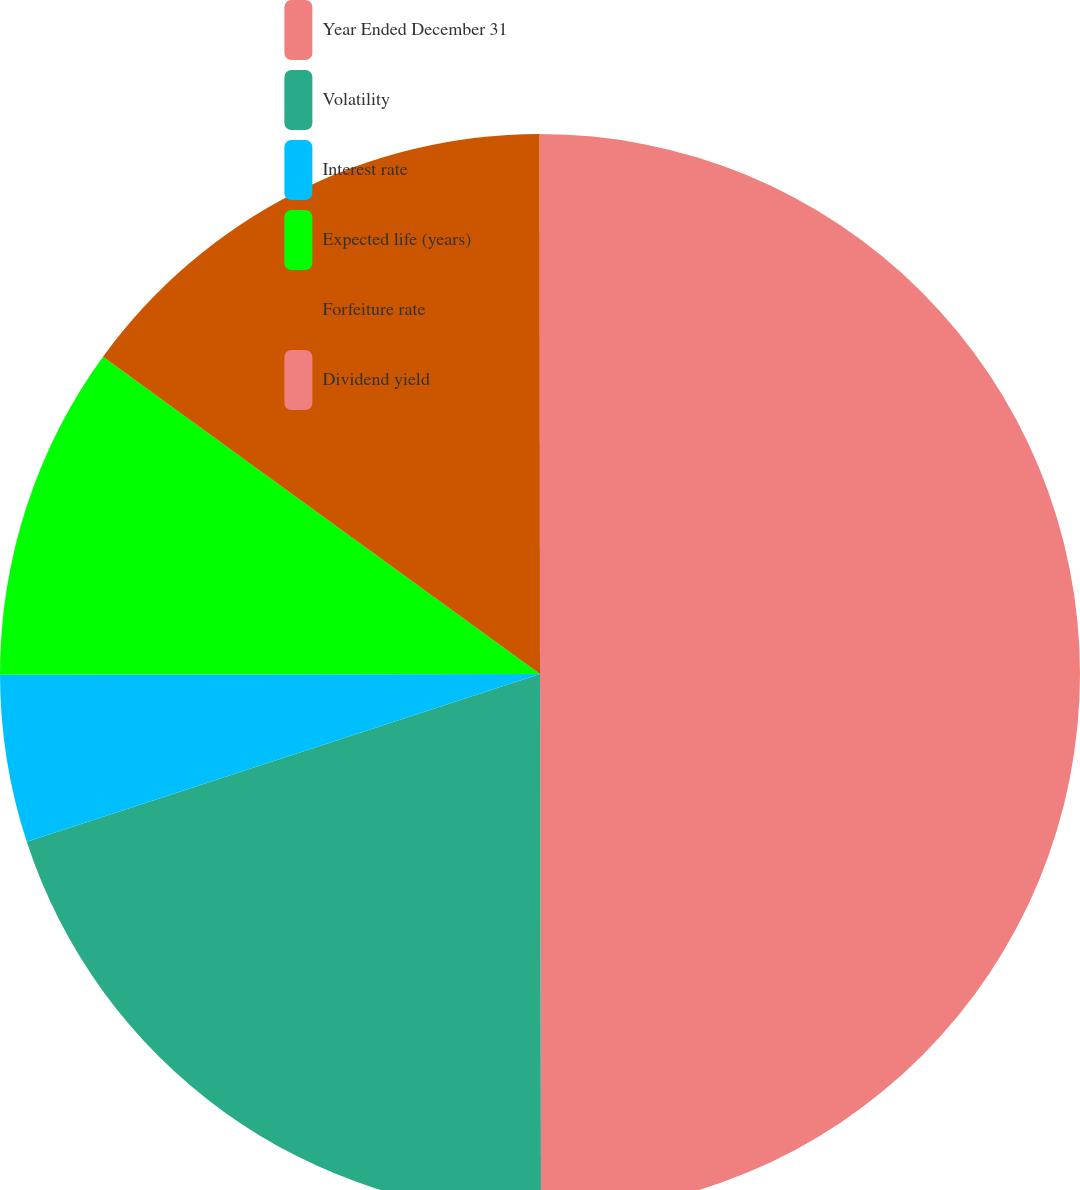Convert chart. <chart><loc_0><loc_0><loc_500><loc_500><pie_chart><fcel>Year Ended December 31<fcel>Volatility<fcel>Interest rate<fcel>Expected life (years)<fcel>Forfeiture rate<fcel>Dividend yield<nl><fcel>49.97%<fcel>20.0%<fcel>5.01%<fcel>10.01%<fcel>15.0%<fcel>0.01%<nl></chart> 